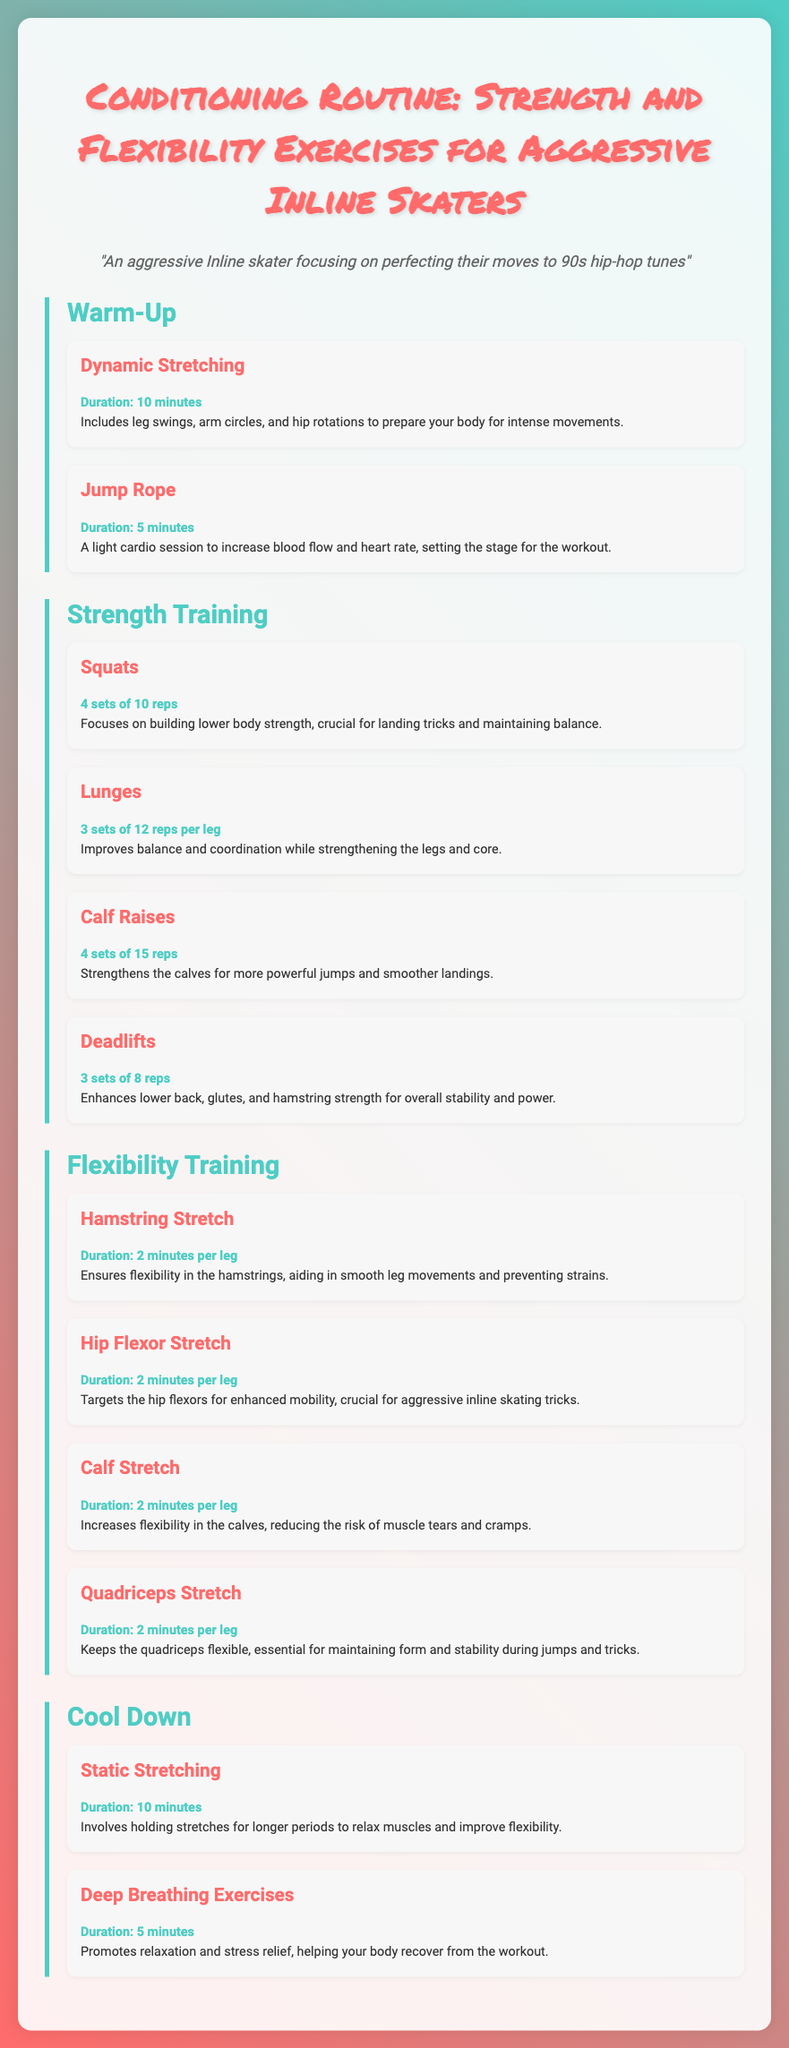what is the duration of dynamic stretching? Dynamic stretching has a specified duration of 10 minutes as mentioned in the warm-up section.
Answer: 10 minutes how many sets of squats are recommended? The document specifies doing 4 sets of squats in the strength training section.
Answer: 4 sets what is one benefit of lunges? Lunges improve balance and coordination while strengthening the legs and core, according to the exercise description.
Answer: Improves balance and coordination how long should calf stretches be held? The duration for calf stretches is indicated to be 2 minutes per leg in the flexibility training section.
Answer: 2 minutes per leg what type of breathing exercises are included in the cool down? The cool down section includes deep breathing exercises aimed at promoting relaxation and stress relief.
Answer: Deep breathing exercises which exercise targets the hip flexors? The hip flexor stretch specifically targets the hip flexors for enhanced mobility as described in the flexibility training section.
Answer: Hip flexor stretch what is the total number of exercises listed in the strength training section? There are four exercises listed in the strength training section: squats, lunges, calf raises, and deadlifts.
Answer: 4 exercises how long is the entire cool down recommended to last? The cool down includes static stretching for 10 minutes and deep breathing exercises for 5 minutes, resulting in a total of 15 minutes.
Answer: 15 minutes 